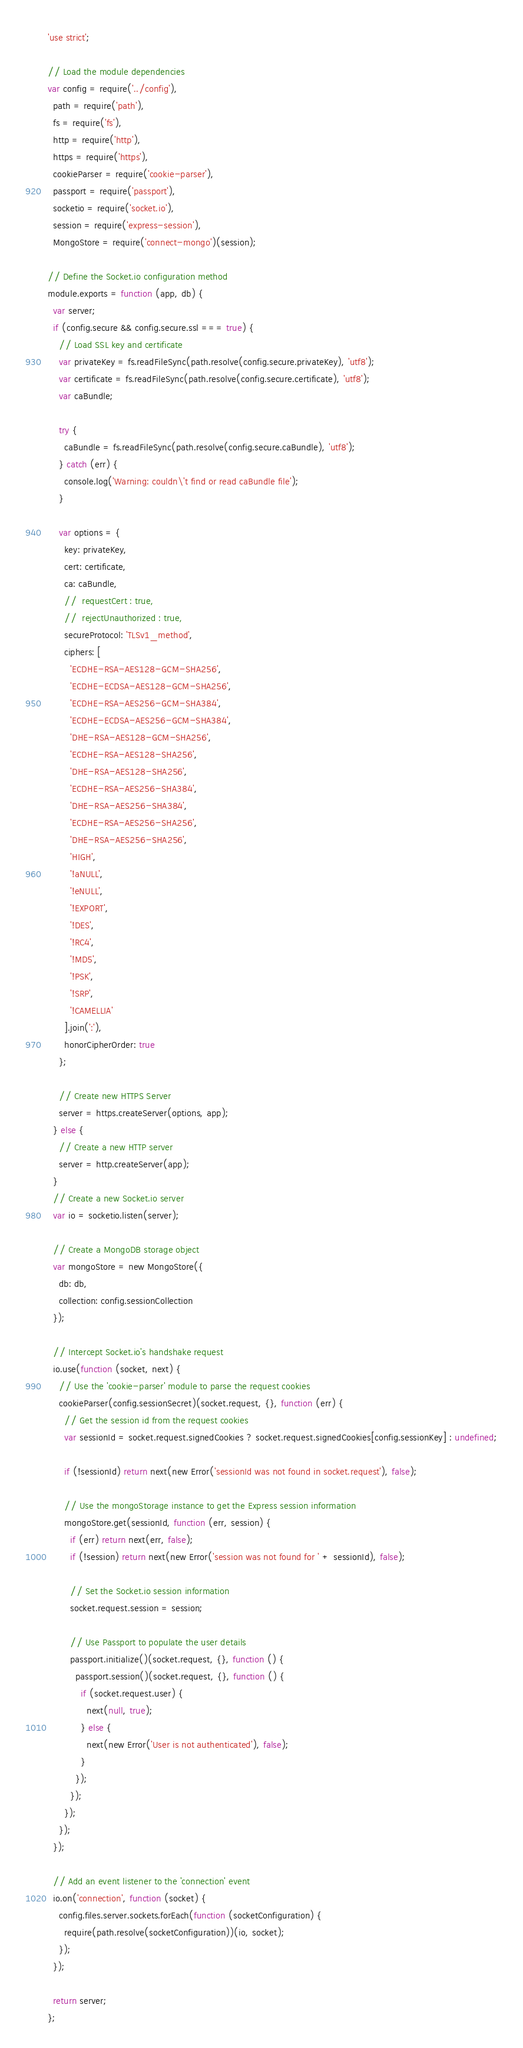<code> <loc_0><loc_0><loc_500><loc_500><_JavaScript_>'use strict';

// Load the module dependencies
var config = require('../config'),
  path = require('path'),
  fs = require('fs'),
  http = require('http'),
  https = require('https'),
  cookieParser = require('cookie-parser'),
  passport = require('passport'),
  socketio = require('socket.io'),
  session = require('express-session'),
  MongoStore = require('connect-mongo')(session);

// Define the Socket.io configuration method
module.exports = function (app, db) {
  var server;
  if (config.secure && config.secure.ssl === true) {
    // Load SSL key and certificate
    var privateKey = fs.readFileSync(path.resolve(config.secure.privateKey), 'utf8');
    var certificate = fs.readFileSync(path.resolve(config.secure.certificate), 'utf8');
    var caBundle;

    try {
      caBundle = fs.readFileSync(path.resolve(config.secure.caBundle), 'utf8');
    } catch (err) {
      console.log('Warning: couldn\'t find or read caBundle file');
    }

    var options = {
      key: privateKey,
      cert: certificate,
      ca: caBundle,
      //  requestCert : true,
      //  rejectUnauthorized : true,
      secureProtocol: 'TLSv1_method',
      ciphers: [
        'ECDHE-RSA-AES128-GCM-SHA256',
        'ECDHE-ECDSA-AES128-GCM-SHA256',
        'ECDHE-RSA-AES256-GCM-SHA384',
        'ECDHE-ECDSA-AES256-GCM-SHA384',
        'DHE-RSA-AES128-GCM-SHA256',
        'ECDHE-RSA-AES128-SHA256',
        'DHE-RSA-AES128-SHA256',
        'ECDHE-RSA-AES256-SHA384',
        'DHE-RSA-AES256-SHA384',
        'ECDHE-RSA-AES256-SHA256',
        'DHE-RSA-AES256-SHA256',
        'HIGH',
        '!aNULL',
        '!eNULL',
        '!EXPORT',
        '!DES',
        '!RC4',
        '!MD5',
        '!PSK',
        '!SRP',
        '!CAMELLIA'
      ].join(':'),
      honorCipherOrder: true
    };

    // Create new HTTPS Server
    server = https.createServer(options, app);
  } else {
    // Create a new HTTP server
    server = http.createServer(app);
  }
  // Create a new Socket.io server
  var io = socketio.listen(server);

  // Create a MongoDB storage object
  var mongoStore = new MongoStore({
    db: db,
    collection: config.sessionCollection
  });

  // Intercept Socket.io's handshake request
  io.use(function (socket, next) {
    // Use the 'cookie-parser' module to parse the request cookies
    cookieParser(config.sessionSecret)(socket.request, {}, function (err) {
      // Get the session id from the request cookies
      var sessionId = socket.request.signedCookies ? socket.request.signedCookies[config.sessionKey] : undefined;

      if (!sessionId) return next(new Error('sessionId was not found in socket.request'), false);

      // Use the mongoStorage instance to get the Express session information
      mongoStore.get(sessionId, function (err, session) {
        if (err) return next(err, false);
        if (!session) return next(new Error('session was not found for ' + sessionId), false);

        // Set the Socket.io session information
        socket.request.session = session;

        // Use Passport to populate the user details
        passport.initialize()(socket.request, {}, function () {
          passport.session()(socket.request, {}, function () {
            if (socket.request.user) {
              next(null, true);
            } else {
              next(new Error('User is not authenticated'), false);
            }
          });
        });
      });
    });
  });

  // Add an event listener to the 'connection' event
  io.on('connection', function (socket) {
    config.files.server.sockets.forEach(function (socketConfiguration) {
      require(path.resolve(socketConfiguration))(io, socket);
    });
  });

  return server;
};
</code> 